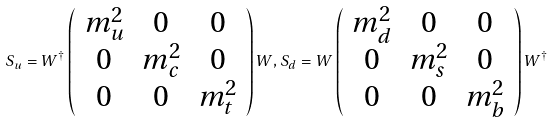Convert formula to latex. <formula><loc_0><loc_0><loc_500><loc_500>S _ { u } = W ^ { \dagger } \left ( \begin{array} { c c c } m ^ { 2 } _ { u } & 0 & 0 \\ 0 & m ^ { 2 } _ { c } & 0 \\ 0 & 0 & m ^ { 2 } _ { t } \end{array} \right ) W , S _ { d } = W \left ( \begin{array} { c c c } m ^ { 2 } _ { d } & 0 & 0 \\ 0 & m ^ { 2 } _ { s } & 0 \\ 0 & 0 & m ^ { 2 } _ { b } \end{array} \right ) W ^ { \dagger }</formula> 